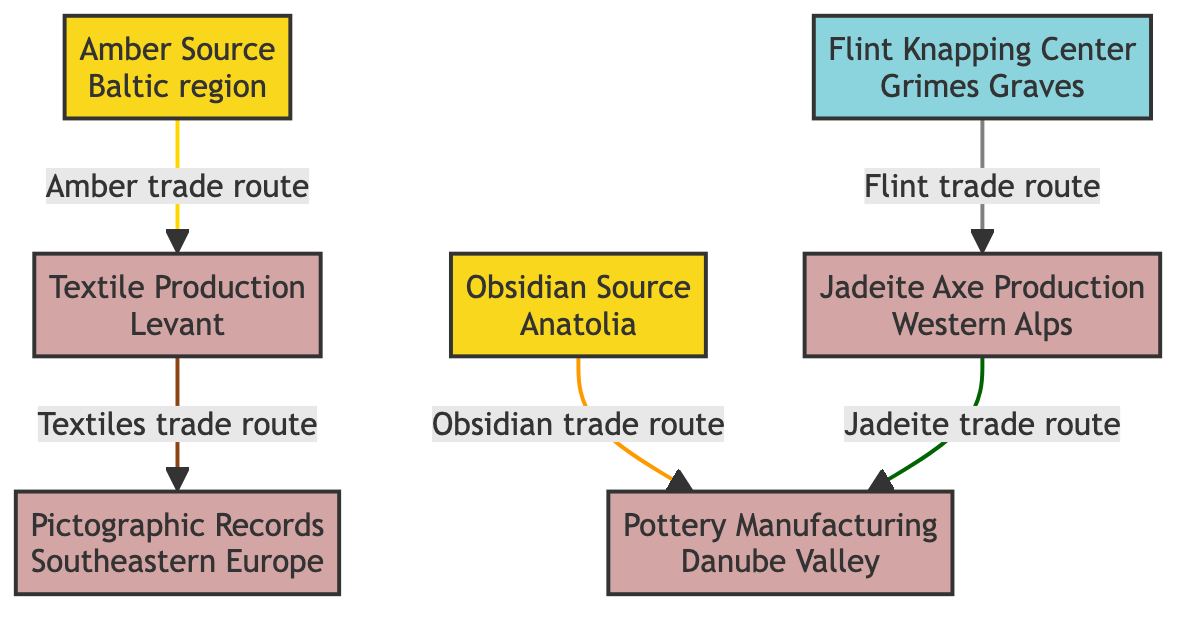What are the sources of traded materials in the diagram? The diagram lists two sources: Obsidian from Anatolia and Amber from the Baltic region. These are shown as nodes that connect to production centers.
Answer: Obsidian, Amber How many production centers are illustrated in the diagram? The diagram contains four production centers: Flint Knapping Center, Jadeite Axe Production, Pottery Manufacturing, and Textile Production. By counting the center nodes, we confirm their total.
Answer: 4 Which trade route connects Obsidian to another production center? The diagram explicitly indicates that the Obsidian source is connected to Pottery Manufacturing through an "Obsidian trade route".
Answer: Pottery Manufacturing What material is produced at the Jadeite Axe Production center? The diagram specifies that Jadeite Axe Production is focused on producing Jadeite axes, as identified by the center's label.
Answer: Jadeite axes Which production center is connected to both Textile Production and Pictographic Records? Tracing the links in the diagram shows that Textile Production leads to Pictographic Records, linking these two production centers directly via the "Textiles trade route".
Answer: Pictographic Records What type of trade route connects Flint Knapping Center to another production center? The diagram distinctly marks the connection as a "Flint trade route," which leads from Flint Knapping Center to Jadeite Axe Production.
Answer: Flint trade route How many total links (trade routes) are shown in the diagram? By carefully counting the connections between the nodes, there are five distinct trade routes illustrated in the diagram connecting various sources and production centers.
Answer: 5 Which trade route is depicted as leading from the Baltic region? The diagram specifies that the Amber source from the Baltic region connects to Textile Production through the "Amber trade route".
Answer: Textile Production What source directly connects to both Pottery Manufacturing and Jadeite Axe Production? Following the links in the diagram, it is observed that Jadeite Axe Production connects to Pottery Manufacturing directly, due to the pathway marked with a "Jadeite trade route".
Answer: Pottery Manufacturing 